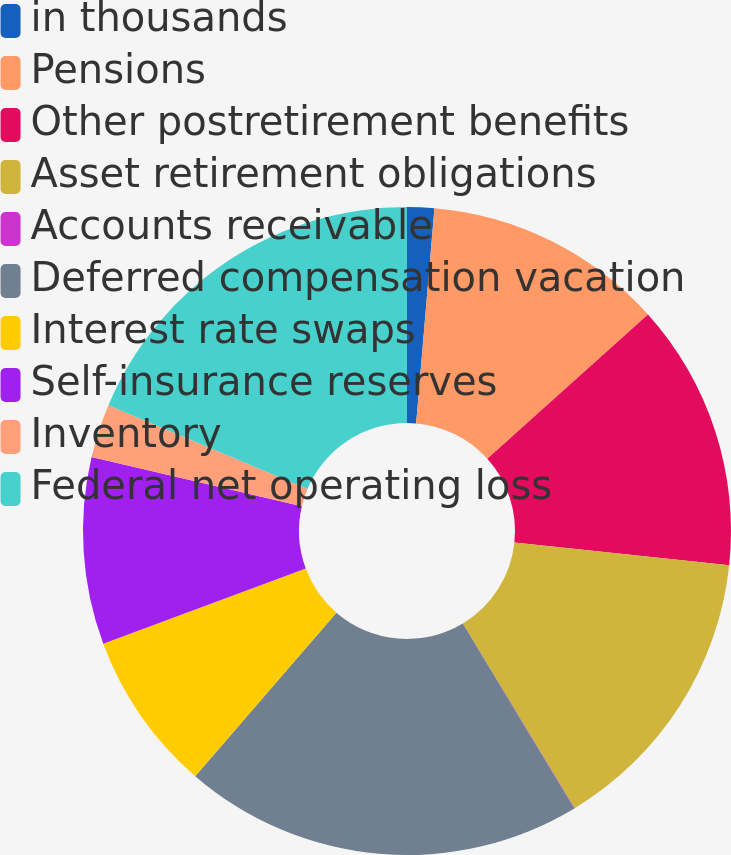Convert chart. <chart><loc_0><loc_0><loc_500><loc_500><pie_chart><fcel>in thousands<fcel>Pensions<fcel>Other postretirement benefits<fcel>Asset retirement obligations<fcel>Accounts receivable<fcel>Deferred compensation vacation<fcel>Interest rate swaps<fcel>Self-insurance reserves<fcel>Inventory<fcel>Federal net operating loss<nl><fcel>1.35%<fcel>12.0%<fcel>13.33%<fcel>14.66%<fcel>0.02%<fcel>19.98%<fcel>8.0%<fcel>9.33%<fcel>2.68%<fcel>18.65%<nl></chart> 